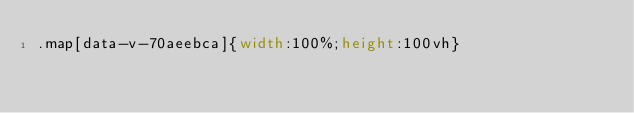<code> <loc_0><loc_0><loc_500><loc_500><_CSS_>.map[data-v-70aeebca]{width:100%;height:100vh}</code> 